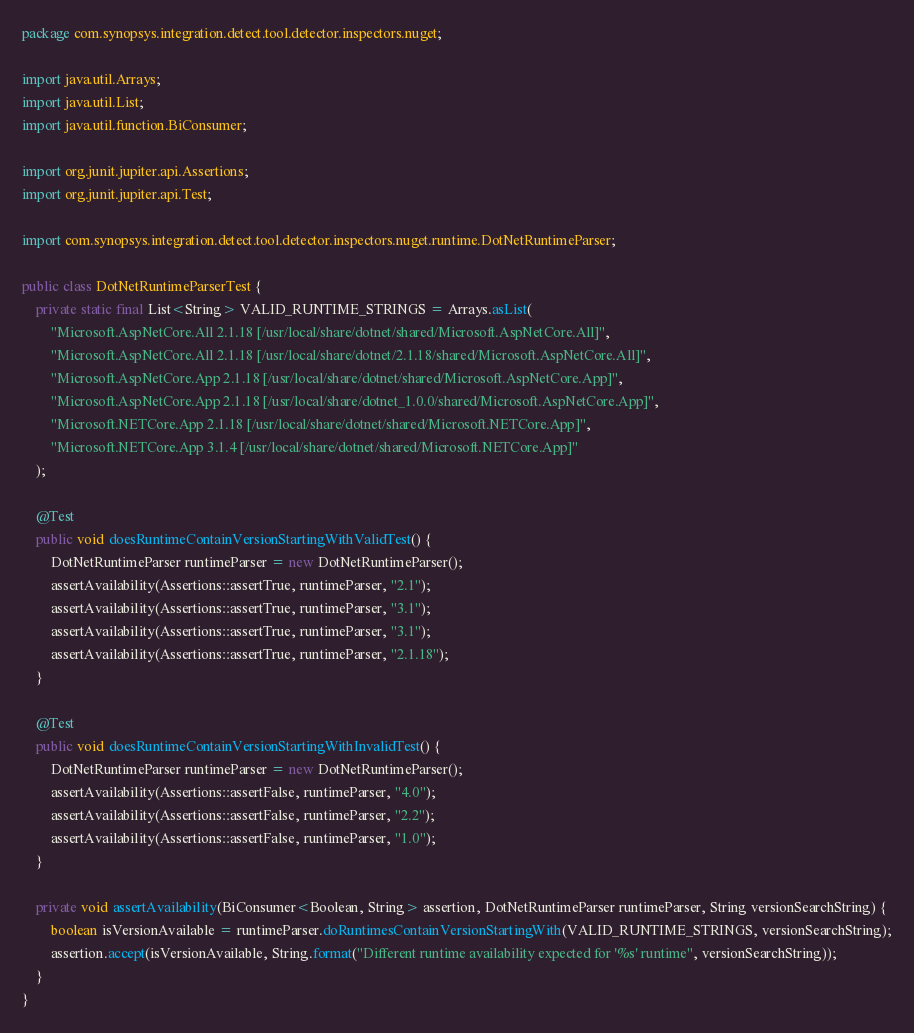Convert code to text. <code><loc_0><loc_0><loc_500><loc_500><_Java_>package com.synopsys.integration.detect.tool.detector.inspectors.nuget;

import java.util.Arrays;
import java.util.List;
import java.util.function.BiConsumer;

import org.junit.jupiter.api.Assertions;
import org.junit.jupiter.api.Test;

import com.synopsys.integration.detect.tool.detector.inspectors.nuget.runtime.DotNetRuntimeParser;

public class DotNetRuntimeParserTest {
    private static final List<String> VALID_RUNTIME_STRINGS = Arrays.asList(
        "Microsoft.AspNetCore.All 2.1.18 [/usr/local/share/dotnet/shared/Microsoft.AspNetCore.All]",
        "Microsoft.AspNetCore.All 2.1.18 [/usr/local/share/dotnet/2.1.18/shared/Microsoft.AspNetCore.All]",
        "Microsoft.AspNetCore.App 2.1.18 [/usr/local/share/dotnet/shared/Microsoft.AspNetCore.App]",
        "Microsoft.AspNetCore.App 2.1.18 [/usr/local/share/dotnet_1.0.0/shared/Microsoft.AspNetCore.App]",
        "Microsoft.NETCore.App 2.1.18 [/usr/local/share/dotnet/shared/Microsoft.NETCore.App]",
        "Microsoft.NETCore.App 3.1.4 [/usr/local/share/dotnet/shared/Microsoft.NETCore.App]"
    );

    @Test
    public void doesRuntimeContainVersionStartingWithValidTest() {
        DotNetRuntimeParser runtimeParser = new DotNetRuntimeParser();
        assertAvailability(Assertions::assertTrue, runtimeParser, "2.1");
        assertAvailability(Assertions::assertTrue, runtimeParser, "3.1");
        assertAvailability(Assertions::assertTrue, runtimeParser, "3.1");
        assertAvailability(Assertions::assertTrue, runtimeParser, "2.1.18");
    }

    @Test
    public void doesRuntimeContainVersionStartingWithInvalidTest() {
        DotNetRuntimeParser runtimeParser = new DotNetRuntimeParser();
        assertAvailability(Assertions::assertFalse, runtimeParser, "4.0");
        assertAvailability(Assertions::assertFalse, runtimeParser, "2.2");
        assertAvailability(Assertions::assertFalse, runtimeParser, "1.0");
    }

    private void assertAvailability(BiConsumer<Boolean, String> assertion, DotNetRuntimeParser runtimeParser, String versionSearchString) {
        boolean isVersionAvailable = runtimeParser.doRuntimesContainVersionStartingWith(VALID_RUNTIME_STRINGS, versionSearchString);
        assertion.accept(isVersionAvailable, String.format("Different runtime availability expected for '%s' runtime", versionSearchString));
    }
}
</code> 